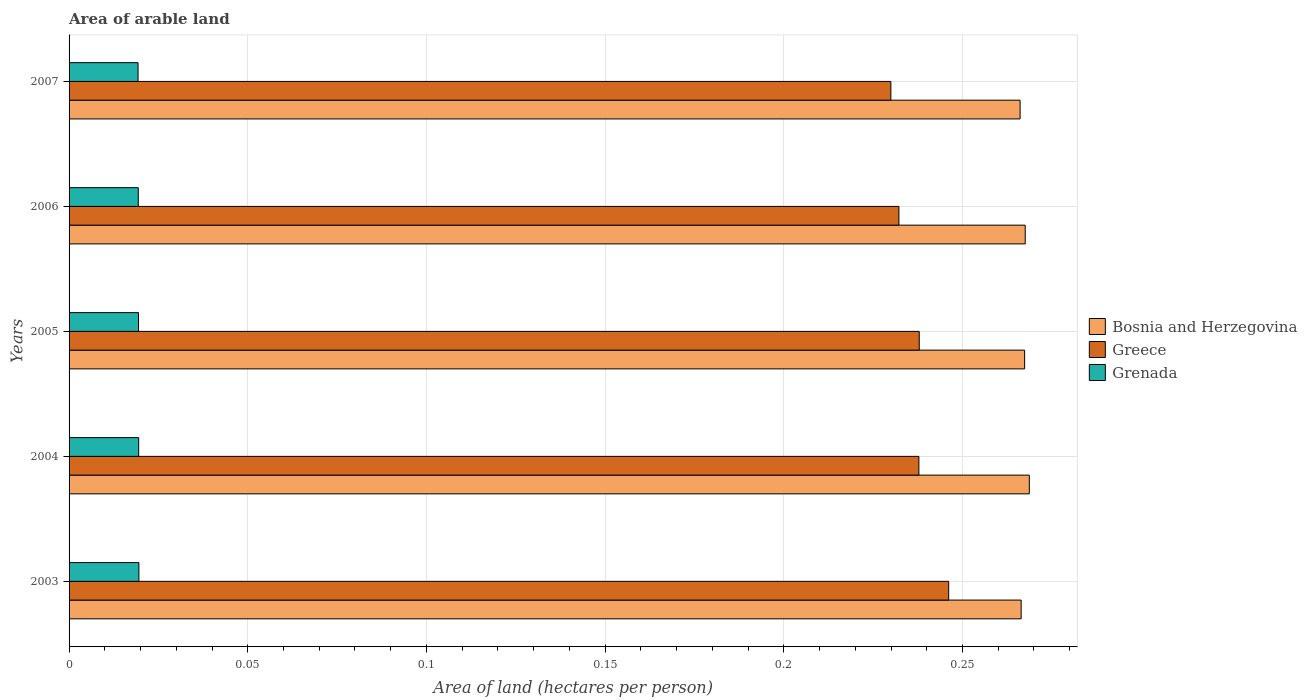How many different coloured bars are there?
Keep it short and to the point. 3. Are the number of bars per tick equal to the number of legend labels?
Your response must be concise. Yes. How many bars are there on the 4th tick from the top?
Your answer should be compact. 3. How many bars are there on the 3rd tick from the bottom?
Your response must be concise. 3. What is the total arable land in Grenada in 2006?
Offer a very short reply. 0.02. Across all years, what is the maximum total arable land in Bosnia and Herzegovina?
Ensure brevity in your answer.  0.27. Across all years, what is the minimum total arable land in Greece?
Your response must be concise. 0.23. In which year was the total arable land in Grenada minimum?
Your response must be concise. 2007. What is the total total arable land in Greece in the graph?
Keep it short and to the point. 1.18. What is the difference between the total arable land in Bosnia and Herzegovina in 2004 and that in 2005?
Your response must be concise. 0. What is the difference between the total arable land in Bosnia and Herzegovina in 2007 and the total arable land in Grenada in 2003?
Provide a succinct answer. 0.25. What is the average total arable land in Bosnia and Herzegovina per year?
Offer a very short reply. 0.27. In the year 2007, what is the difference between the total arable land in Grenada and total arable land in Bosnia and Herzegovina?
Give a very brief answer. -0.25. In how many years, is the total arable land in Greece greater than 0.05 hectares per person?
Your answer should be compact. 5. What is the ratio of the total arable land in Bosnia and Herzegovina in 2003 to that in 2006?
Keep it short and to the point. 1. What is the difference between the highest and the second highest total arable land in Greece?
Ensure brevity in your answer.  0.01. What is the difference between the highest and the lowest total arable land in Greece?
Keep it short and to the point. 0.02. In how many years, is the total arable land in Bosnia and Herzegovina greater than the average total arable land in Bosnia and Herzegovina taken over all years?
Offer a terse response. 3. What does the 3rd bar from the top in 2004 represents?
Ensure brevity in your answer.  Bosnia and Herzegovina. What does the 2nd bar from the bottom in 2003 represents?
Keep it short and to the point. Greece. Does the graph contain grids?
Provide a succinct answer. Yes. Where does the legend appear in the graph?
Your response must be concise. Center right. What is the title of the graph?
Ensure brevity in your answer.  Area of arable land. What is the label or title of the X-axis?
Ensure brevity in your answer.  Area of land (hectares per person). What is the label or title of the Y-axis?
Make the answer very short. Years. What is the Area of land (hectares per person) in Bosnia and Herzegovina in 2003?
Give a very brief answer. 0.27. What is the Area of land (hectares per person) in Greece in 2003?
Ensure brevity in your answer.  0.25. What is the Area of land (hectares per person) of Grenada in 2003?
Offer a very short reply. 0.02. What is the Area of land (hectares per person) in Bosnia and Herzegovina in 2004?
Provide a succinct answer. 0.27. What is the Area of land (hectares per person) in Greece in 2004?
Ensure brevity in your answer.  0.24. What is the Area of land (hectares per person) of Grenada in 2004?
Your answer should be very brief. 0.02. What is the Area of land (hectares per person) of Bosnia and Herzegovina in 2005?
Provide a succinct answer. 0.27. What is the Area of land (hectares per person) of Greece in 2005?
Keep it short and to the point. 0.24. What is the Area of land (hectares per person) of Grenada in 2005?
Provide a succinct answer. 0.02. What is the Area of land (hectares per person) of Bosnia and Herzegovina in 2006?
Provide a succinct answer. 0.27. What is the Area of land (hectares per person) in Greece in 2006?
Offer a very short reply. 0.23. What is the Area of land (hectares per person) of Grenada in 2006?
Your answer should be very brief. 0.02. What is the Area of land (hectares per person) of Bosnia and Herzegovina in 2007?
Offer a very short reply. 0.27. What is the Area of land (hectares per person) in Greece in 2007?
Offer a terse response. 0.23. What is the Area of land (hectares per person) of Grenada in 2007?
Provide a short and direct response. 0.02. Across all years, what is the maximum Area of land (hectares per person) of Bosnia and Herzegovina?
Ensure brevity in your answer.  0.27. Across all years, what is the maximum Area of land (hectares per person) of Greece?
Keep it short and to the point. 0.25. Across all years, what is the maximum Area of land (hectares per person) of Grenada?
Your answer should be very brief. 0.02. Across all years, what is the minimum Area of land (hectares per person) in Bosnia and Herzegovina?
Your answer should be compact. 0.27. Across all years, what is the minimum Area of land (hectares per person) in Greece?
Make the answer very short. 0.23. Across all years, what is the minimum Area of land (hectares per person) in Grenada?
Your response must be concise. 0.02. What is the total Area of land (hectares per person) of Bosnia and Herzegovina in the graph?
Make the answer very short. 1.34. What is the total Area of land (hectares per person) of Greece in the graph?
Provide a succinct answer. 1.18. What is the total Area of land (hectares per person) in Grenada in the graph?
Ensure brevity in your answer.  0.1. What is the difference between the Area of land (hectares per person) of Bosnia and Herzegovina in 2003 and that in 2004?
Your response must be concise. -0. What is the difference between the Area of land (hectares per person) of Greece in 2003 and that in 2004?
Your answer should be compact. 0.01. What is the difference between the Area of land (hectares per person) in Grenada in 2003 and that in 2004?
Provide a short and direct response. 0. What is the difference between the Area of land (hectares per person) of Bosnia and Herzegovina in 2003 and that in 2005?
Provide a succinct answer. -0. What is the difference between the Area of land (hectares per person) of Greece in 2003 and that in 2005?
Keep it short and to the point. 0.01. What is the difference between the Area of land (hectares per person) of Bosnia and Herzegovina in 2003 and that in 2006?
Offer a terse response. -0. What is the difference between the Area of land (hectares per person) in Greece in 2003 and that in 2006?
Give a very brief answer. 0.01. What is the difference between the Area of land (hectares per person) in Bosnia and Herzegovina in 2003 and that in 2007?
Make the answer very short. 0. What is the difference between the Area of land (hectares per person) of Greece in 2003 and that in 2007?
Your answer should be very brief. 0.02. What is the difference between the Area of land (hectares per person) of Grenada in 2003 and that in 2007?
Offer a very short reply. 0. What is the difference between the Area of land (hectares per person) of Bosnia and Herzegovina in 2004 and that in 2005?
Your answer should be compact. 0. What is the difference between the Area of land (hectares per person) of Greece in 2004 and that in 2005?
Give a very brief answer. -0. What is the difference between the Area of land (hectares per person) in Bosnia and Herzegovina in 2004 and that in 2006?
Your answer should be compact. 0. What is the difference between the Area of land (hectares per person) of Greece in 2004 and that in 2006?
Your answer should be compact. 0.01. What is the difference between the Area of land (hectares per person) of Grenada in 2004 and that in 2006?
Your response must be concise. 0. What is the difference between the Area of land (hectares per person) of Bosnia and Herzegovina in 2004 and that in 2007?
Provide a succinct answer. 0. What is the difference between the Area of land (hectares per person) of Greece in 2004 and that in 2007?
Ensure brevity in your answer.  0.01. What is the difference between the Area of land (hectares per person) in Bosnia and Herzegovina in 2005 and that in 2006?
Your answer should be very brief. -0. What is the difference between the Area of land (hectares per person) of Greece in 2005 and that in 2006?
Provide a short and direct response. 0.01. What is the difference between the Area of land (hectares per person) in Grenada in 2005 and that in 2006?
Your response must be concise. 0. What is the difference between the Area of land (hectares per person) of Bosnia and Herzegovina in 2005 and that in 2007?
Make the answer very short. 0. What is the difference between the Area of land (hectares per person) of Greece in 2005 and that in 2007?
Your answer should be very brief. 0.01. What is the difference between the Area of land (hectares per person) in Grenada in 2005 and that in 2007?
Ensure brevity in your answer.  0. What is the difference between the Area of land (hectares per person) in Bosnia and Herzegovina in 2006 and that in 2007?
Offer a very short reply. 0. What is the difference between the Area of land (hectares per person) of Greece in 2006 and that in 2007?
Your answer should be very brief. 0. What is the difference between the Area of land (hectares per person) in Grenada in 2006 and that in 2007?
Give a very brief answer. 0. What is the difference between the Area of land (hectares per person) in Bosnia and Herzegovina in 2003 and the Area of land (hectares per person) in Greece in 2004?
Your answer should be compact. 0.03. What is the difference between the Area of land (hectares per person) of Bosnia and Herzegovina in 2003 and the Area of land (hectares per person) of Grenada in 2004?
Your answer should be very brief. 0.25. What is the difference between the Area of land (hectares per person) of Greece in 2003 and the Area of land (hectares per person) of Grenada in 2004?
Offer a very short reply. 0.23. What is the difference between the Area of land (hectares per person) of Bosnia and Herzegovina in 2003 and the Area of land (hectares per person) of Greece in 2005?
Offer a very short reply. 0.03. What is the difference between the Area of land (hectares per person) of Bosnia and Herzegovina in 2003 and the Area of land (hectares per person) of Grenada in 2005?
Provide a short and direct response. 0.25. What is the difference between the Area of land (hectares per person) of Greece in 2003 and the Area of land (hectares per person) of Grenada in 2005?
Ensure brevity in your answer.  0.23. What is the difference between the Area of land (hectares per person) in Bosnia and Herzegovina in 2003 and the Area of land (hectares per person) in Greece in 2006?
Provide a succinct answer. 0.03. What is the difference between the Area of land (hectares per person) of Bosnia and Herzegovina in 2003 and the Area of land (hectares per person) of Grenada in 2006?
Provide a succinct answer. 0.25. What is the difference between the Area of land (hectares per person) in Greece in 2003 and the Area of land (hectares per person) in Grenada in 2006?
Give a very brief answer. 0.23. What is the difference between the Area of land (hectares per person) in Bosnia and Herzegovina in 2003 and the Area of land (hectares per person) in Greece in 2007?
Offer a terse response. 0.04. What is the difference between the Area of land (hectares per person) of Bosnia and Herzegovina in 2003 and the Area of land (hectares per person) of Grenada in 2007?
Provide a short and direct response. 0.25. What is the difference between the Area of land (hectares per person) of Greece in 2003 and the Area of land (hectares per person) of Grenada in 2007?
Offer a very short reply. 0.23. What is the difference between the Area of land (hectares per person) in Bosnia and Herzegovina in 2004 and the Area of land (hectares per person) in Greece in 2005?
Make the answer very short. 0.03. What is the difference between the Area of land (hectares per person) of Bosnia and Herzegovina in 2004 and the Area of land (hectares per person) of Grenada in 2005?
Keep it short and to the point. 0.25. What is the difference between the Area of land (hectares per person) in Greece in 2004 and the Area of land (hectares per person) in Grenada in 2005?
Offer a terse response. 0.22. What is the difference between the Area of land (hectares per person) in Bosnia and Herzegovina in 2004 and the Area of land (hectares per person) in Greece in 2006?
Keep it short and to the point. 0.04. What is the difference between the Area of land (hectares per person) of Bosnia and Herzegovina in 2004 and the Area of land (hectares per person) of Grenada in 2006?
Your response must be concise. 0.25. What is the difference between the Area of land (hectares per person) of Greece in 2004 and the Area of land (hectares per person) of Grenada in 2006?
Provide a short and direct response. 0.22. What is the difference between the Area of land (hectares per person) of Bosnia and Herzegovina in 2004 and the Area of land (hectares per person) of Greece in 2007?
Your answer should be very brief. 0.04. What is the difference between the Area of land (hectares per person) of Bosnia and Herzegovina in 2004 and the Area of land (hectares per person) of Grenada in 2007?
Your answer should be compact. 0.25. What is the difference between the Area of land (hectares per person) of Greece in 2004 and the Area of land (hectares per person) of Grenada in 2007?
Your answer should be very brief. 0.22. What is the difference between the Area of land (hectares per person) in Bosnia and Herzegovina in 2005 and the Area of land (hectares per person) in Greece in 2006?
Your answer should be compact. 0.04. What is the difference between the Area of land (hectares per person) in Bosnia and Herzegovina in 2005 and the Area of land (hectares per person) in Grenada in 2006?
Your answer should be compact. 0.25. What is the difference between the Area of land (hectares per person) of Greece in 2005 and the Area of land (hectares per person) of Grenada in 2006?
Keep it short and to the point. 0.22. What is the difference between the Area of land (hectares per person) of Bosnia and Herzegovina in 2005 and the Area of land (hectares per person) of Greece in 2007?
Keep it short and to the point. 0.04. What is the difference between the Area of land (hectares per person) of Bosnia and Herzegovina in 2005 and the Area of land (hectares per person) of Grenada in 2007?
Give a very brief answer. 0.25. What is the difference between the Area of land (hectares per person) of Greece in 2005 and the Area of land (hectares per person) of Grenada in 2007?
Provide a succinct answer. 0.22. What is the difference between the Area of land (hectares per person) of Bosnia and Herzegovina in 2006 and the Area of land (hectares per person) of Greece in 2007?
Make the answer very short. 0.04. What is the difference between the Area of land (hectares per person) in Bosnia and Herzegovina in 2006 and the Area of land (hectares per person) in Grenada in 2007?
Offer a terse response. 0.25. What is the difference between the Area of land (hectares per person) of Greece in 2006 and the Area of land (hectares per person) of Grenada in 2007?
Your answer should be compact. 0.21. What is the average Area of land (hectares per person) of Bosnia and Herzegovina per year?
Provide a short and direct response. 0.27. What is the average Area of land (hectares per person) of Greece per year?
Your answer should be compact. 0.24. What is the average Area of land (hectares per person) of Grenada per year?
Your answer should be very brief. 0.02. In the year 2003, what is the difference between the Area of land (hectares per person) of Bosnia and Herzegovina and Area of land (hectares per person) of Greece?
Provide a short and direct response. 0.02. In the year 2003, what is the difference between the Area of land (hectares per person) in Bosnia and Herzegovina and Area of land (hectares per person) in Grenada?
Provide a short and direct response. 0.25. In the year 2003, what is the difference between the Area of land (hectares per person) in Greece and Area of land (hectares per person) in Grenada?
Offer a very short reply. 0.23. In the year 2004, what is the difference between the Area of land (hectares per person) of Bosnia and Herzegovina and Area of land (hectares per person) of Greece?
Provide a succinct answer. 0.03. In the year 2004, what is the difference between the Area of land (hectares per person) in Bosnia and Herzegovina and Area of land (hectares per person) in Grenada?
Offer a terse response. 0.25. In the year 2004, what is the difference between the Area of land (hectares per person) in Greece and Area of land (hectares per person) in Grenada?
Offer a very short reply. 0.22. In the year 2005, what is the difference between the Area of land (hectares per person) in Bosnia and Herzegovina and Area of land (hectares per person) in Greece?
Give a very brief answer. 0.03. In the year 2005, what is the difference between the Area of land (hectares per person) of Bosnia and Herzegovina and Area of land (hectares per person) of Grenada?
Your answer should be compact. 0.25. In the year 2005, what is the difference between the Area of land (hectares per person) of Greece and Area of land (hectares per person) of Grenada?
Your response must be concise. 0.22. In the year 2006, what is the difference between the Area of land (hectares per person) in Bosnia and Herzegovina and Area of land (hectares per person) in Greece?
Give a very brief answer. 0.04. In the year 2006, what is the difference between the Area of land (hectares per person) of Bosnia and Herzegovina and Area of land (hectares per person) of Grenada?
Ensure brevity in your answer.  0.25. In the year 2006, what is the difference between the Area of land (hectares per person) of Greece and Area of land (hectares per person) of Grenada?
Keep it short and to the point. 0.21. In the year 2007, what is the difference between the Area of land (hectares per person) in Bosnia and Herzegovina and Area of land (hectares per person) in Greece?
Give a very brief answer. 0.04. In the year 2007, what is the difference between the Area of land (hectares per person) of Bosnia and Herzegovina and Area of land (hectares per person) of Grenada?
Make the answer very short. 0.25. In the year 2007, what is the difference between the Area of land (hectares per person) in Greece and Area of land (hectares per person) in Grenada?
Provide a short and direct response. 0.21. What is the ratio of the Area of land (hectares per person) in Greece in 2003 to that in 2004?
Provide a short and direct response. 1.04. What is the ratio of the Area of land (hectares per person) of Greece in 2003 to that in 2005?
Keep it short and to the point. 1.03. What is the ratio of the Area of land (hectares per person) of Greece in 2003 to that in 2006?
Your response must be concise. 1.06. What is the ratio of the Area of land (hectares per person) of Grenada in 2003 to that in 2006?
Give a very brief answer. 1.01. What is the ratio of the Area of land (hectares per person) in Bosnia and Herzegovina in 2003 to that in 2007?
Offer a terse response. 1. What is the ratio of the Area of land (hectares per person) of Greece in 2003 to that in 2007?
Keep it short and to the point. 1.07. What is the ratio of the Area of land (hectares per person) of Grenada in 2003 to that in 2007?
Provide a short and direct response. 1.01. What is the ratio of the Area of land (hectares per person) in Bosnia and Herzegovina in 2004 to that in 2005?
Provide a short and direct response. 1. What is the ratio of the Area of land (hectares per person) in Grenada in 2004 to that in 2005?
Your answer should be compact. 1. What is the ratio of the Area of land (hectares per person) in Bosnia and Herzegovina in 2004 to that in 2006?
Keep it short and to the point. 1. What is the ratio of the Area of land (hectares per person) of Greece in 2004 to that in 2006?
Keep it short and to the point. 1.02. What is the ratio of the Area of land (hectares per person) in Grenada in 2004 to that in 2006?
Provide a succinct answer. 1.01. What is the ratio of the Area of land (hectares per person) in Bosnia and Herzegovina in 2004 to that in 2007?
Offer a very short reply. 1.01. What is the ratio of the Area of land (hectares per person) in Greece in 2004 to that in 2007?
Make the answer very short. 1.03. What is the ratio of the Area of land (hectares per person) of Grenada in 2004 to that in 2007?
Offer a very short reply. 1.01. What is the ratio of the Area of land (hectares per person) of Bosnia and Herzegovina in 2005 to that in 2006?
Offer a very short reply. 1. What is the ratio of the Area of land (hectares per person) in Greece in 2005 to that in 2006?
Give a very brief answer. 1.02. What is the ratio of the Area of land (hectares per person) in Bosnia and Herzegovina in 2005 to that in 2007?
Your response must be concise. 1. What is the ratio of the Area of land (hectares per person) in Greece in 2005 to that in 2007?
Ensure brevity in your answer.  1.03. What is the ratio of the Area of land (hectares per person) of Bosnia and Herzegovina in 2006 to that in 2007?
Keep it short and to the point. 1.01. What is the ratio of the Area of land (hectares per person) in Greece in 2006 to that in 2007?
Provide a short and direct response. 1.01. What is the ratio of the Area of land (hectares per person) in Grenada in 2006 to that in 2007?
Offer a very short reply. 1. What is the difference between the highest and the second highest Area of land (hectares per person) in Bosnia and Herzegovina?
Your answer should be compact. 0. What is the difference between the highest and the second highest Area of land (hectares per person) in Greece?
Offer a terse response. 0.01. What is the difference between the highest and the second highest Area of land (hectares per person) of Grenada?
Your response must be concise. 0. What is the difference between the highest and the lowest Area of land (hectares per person) of Bosnia and Herzegovina?
Provide a succinct answer. 0. What is the difference between the highest and the lowest Area of land (hectares per person) in Greece?
Make the answer very short. 0.02. 